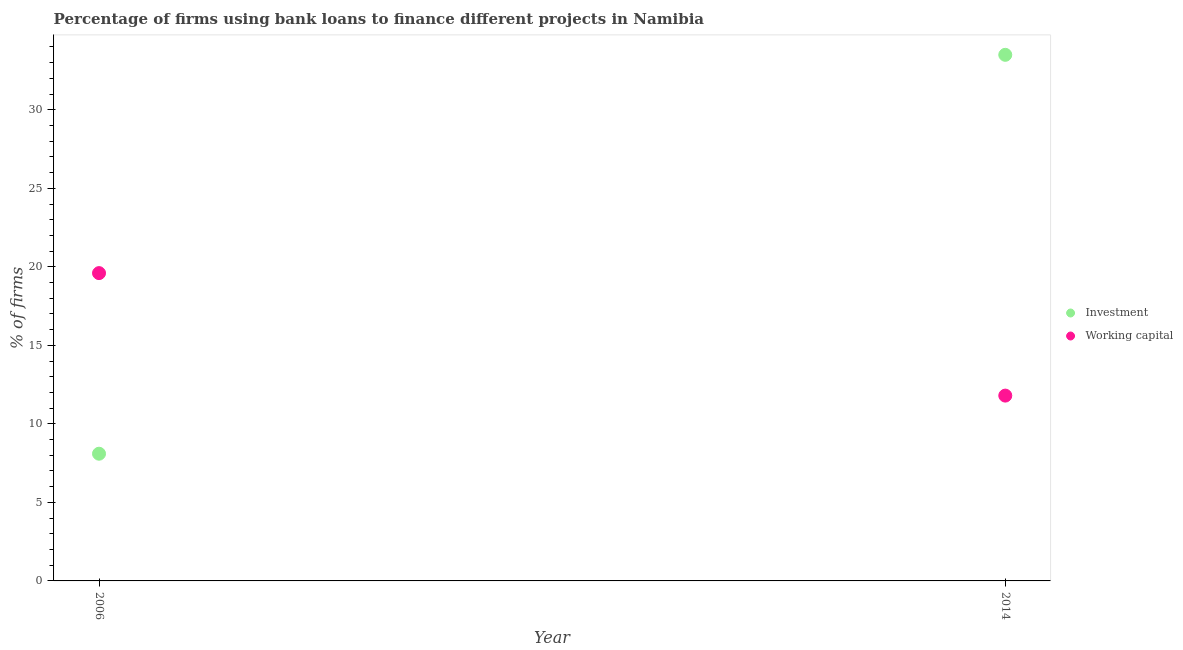How many different coloured dotlines are there?
Make the answer very short. 2. Across all years, what is the maximum percentage of firms using banks to finance working capital?
Provide a succinct answer. 19.6. Across all years, what is the minimum percentage of firms using banks to finance working capital?
Your answer should be very brief. 11.8. What is the total percentage of firms using banks to finance investment in the graph?
Provide a short and direct response. 41.6. What is the difference between the percentage of firms using banks to finance investment in 2006 and that in 2014?
Your answer should be very brief. -25.4. What is the difference between the percentage of firms using banks to finance investment in 2014 and the percentage of firms using banks to finance working capital in 2006?
Make the answer very short. 13.9. What is the average percentage of firms using banks to finance working capital per year?
Your answer should be compact. 15.7. In the year 2006, what is the difference between the percentage of firms using banks to finance working capital and percentage of firms using banks to finance investment?
Your response must be concise. 11.5. In how many years, is the percentage of firms using banks to finance investment greater than 5 %?
Your answer should be very brief. 2. What is the ratio of the percentage of firms using banks to finance investment in 2006 to that in 2014?
Make the answer very short. 0.24. Is the percentage of firms using banks to finance investment in 2006 less than that in 2014?
Make the answer very short. Yes. Is the percentage of firms using banks to finance investment strictly greater than the percentage of firms using banks to finance working capital over the years?
Your response must be concise. No. Is the percentage of firms using banks to finance working capital strictly less than the percentage of firms using banks to finance investment over the years?
Offer a terse response. No. Does the graph contain grids?
Provide a short and direct response. No. Where does the legend appear in the graph?
Offer a terse response. Center right. What is the title of the graph?
Keep it short and to the point. Percentage of firms using bank loans to finance different projects in Namibia. Does "Register a property" appear as one of the legend labels in the graph?
Provide a short and direct response. No. What is the label or title of the X-axis?
Keep it short and to the point. Year. What is the label or title of the Y-axis?
Provide a short and direct response. % of firms. What is the % of firms in Working capital in 2006?
Give a very brief answer. 19.6. What is the % of firms of Investment in 2014?
Give a very brief answer. 33.5. Across all years, what is the maximum % of firms in Investment?
Provide a succinct answer. 33.5. Across all years, what is the maximum % of firms in Working capital?
Offer a terse response. 19.6. Across all years, what is the minimum % of firms in Investment?
Provide a short and direct response. 8.1. What is the total % of firms of Investment in the graph?
Offer a terse response. 41.6. What is the total % of firms of Working capital in the graph?
Offer a terse response. 31.4. What is the difference between the % of firms of Investment in 2006 and that in 2014?
Ensure brevity in your answer.  -25.4. What is the average % of firms of Investment per year?
Keep it short and to the point. 20.8. What is the average % of firms in Working capital per year?
Your response must be concise. 15.7. In the year 2006, what is the difference between the % of firms of Investment and % of firms of Working capital?
Ensure brevity in your answer.  -11.5. In the year 2014, what is the difference between the % of firms in Investment and % of firms in Working capital?
Offer a terse response. 21.7. What is the ratio of the % of firms of Investment in 2006 to that in 2014?
Make the answer very short. 0.24. What is the ratio of the % of firms in Working capital in 2006 to that in 2014?
Your answer should be very brief. 1.66. What is the difference between the highest and the second highest % of firms in Investment?
Your answer should be compact. 25.4. What is the difference between the highest and the second highest % of firms in Working capital?
Offer a terse response. 7.8. What is the difference between the highest and the lowest % of firms of Investment?
Keep it short and to the point. 25.4. 